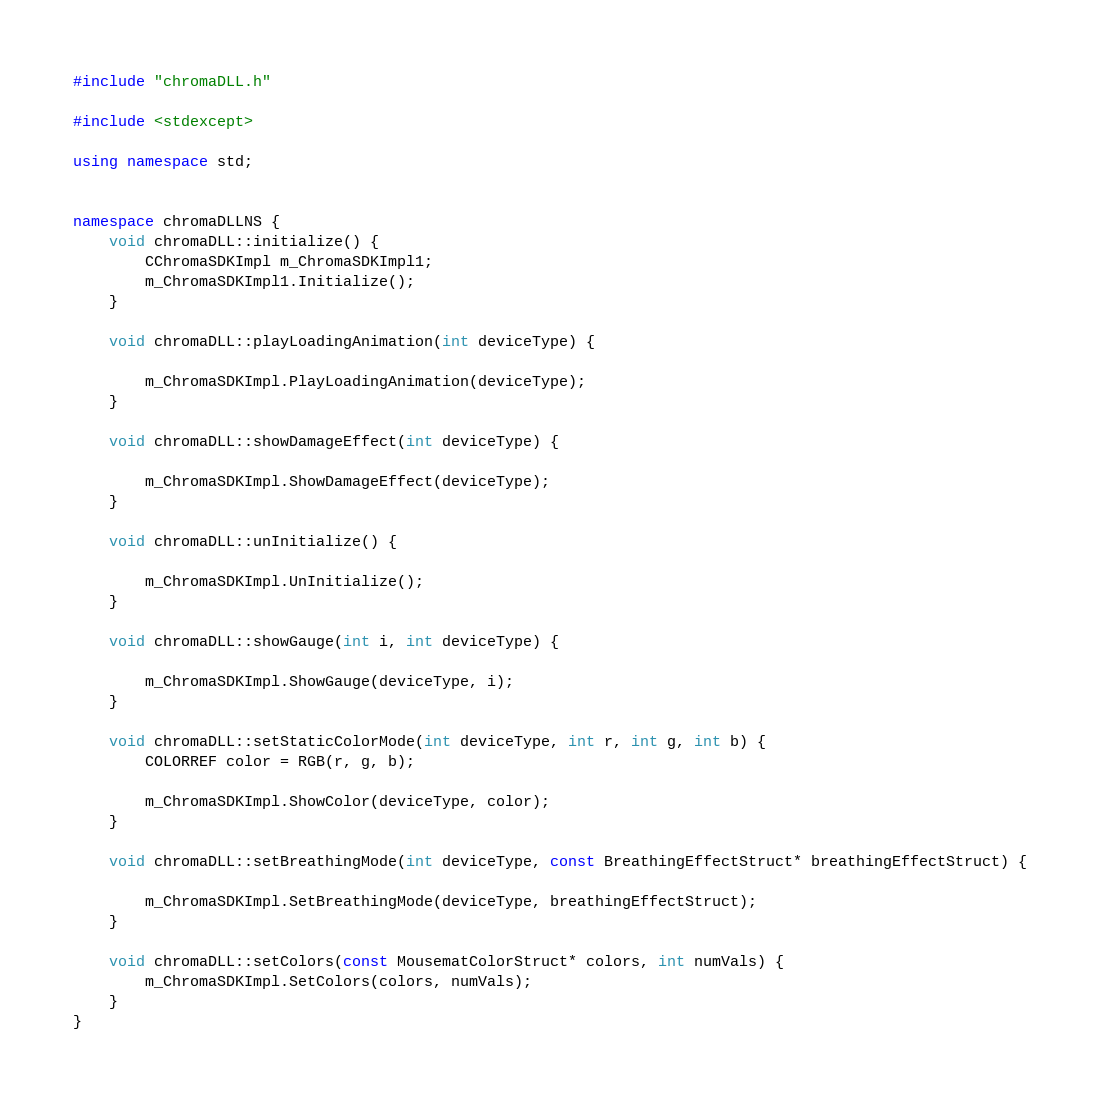<code> <loc_0><loc_0><loc_500><loc_500><_C++_>#include "chromaDLL.h"

#include <stdexcept>

using namespace std;


namespace chromaDLLNS {
	void chromaDLL::initialize() {
		CChromaSDKImpl m_ChromaSDKImpl1;
		m_ChromaSDKImpl1.Initialize();
	}

	void chromaDLL::playLoadingAnimation(int deviceType) {

		m_ChromaSDKImpl.PlayLoadingAnimation(deviceType);
	}

	void chromaDLL::showDamageEffect(int deviceType) {

		m_ChromaSDKImpl.ShowDamageEffect(deviceType);
	}

	void chromaDLL::unInitialize() {

		m_ChromaSDKImpl.UnInitialize();
	}

	void chromaDLL::showGauge(int i, int deviceType) {

		m_ChromaSDKImpl.ShowGauge(deviceType, i);
	}

	void chromaDLL::setStaticColorMode(int deviceType, int r, int g, int b) {
		COLORREF color = RGB(r, g, b);

		m_ChromaSDKImpl.ShowColor(deviceType, color);
	}

	void chromaDLL::setBreathingMode(int deviceType, const BreathingEffectStruct* breathingEffectStruct) {

		m_ChromaSDKImpl.SetBreathingMode(deviceType, breathingEffectStruct);
	}

	void chromaDLL::setColors(const MousematColorStruct* colors, int numVals) {
		m_ChromaSDKImpl.SetColors(colors, numVals);
	}
}</code> 